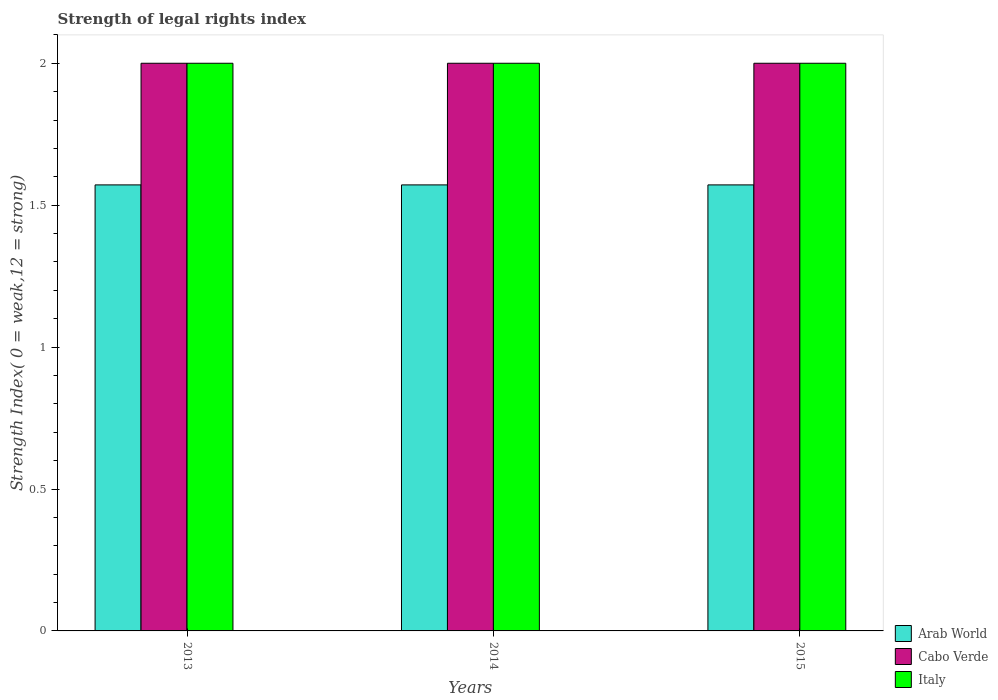How many different coloured bars are there?
Offer a terse response. 3. Are the number of bars per tick equal to the number of legend labels?
Keep it short and to the point. Yes. Are the number of bars on each tick of the X-axis equal?
Give a very brief answer. Yes. What is the label of the 3rd group of bars from the left?
Offer a terse response. 2015. What is the strength index in Italy in 2015?
Give a very brief answer. 2. Across all years, what is the maximum strength index in Arab World?
Offer a terse response. 1.57. Across all years, what is the minimum strength index in Arab World?
Provide a succinct answer. 1.57. In which year was the strength index in Cabo Verde maximum?
Keep it short and to the point. 2013. In which year was the strength index in Arab World minimum?
Provide a succinct answer. 2013. What is the difference between the strength index in Arab World in 2015 and the strength index in Italy in 2013?
Ensure brevity in your answer.  -0.43. What is the average strength index in Arab World per year?
Your answer should be compact. 1.57. In how many years, is the strength index in Cabo Verde greater than 0.5?
Make the answer very short. 3. Is the strength index in Italy in 2013 less than that in 2015?
Ensure brevity in your answer.  No. Is the difference between the strength index in Italy in 2013 and 2014 greater than the difference between the strength index in Cabo Verde in 2013 and 2014?
Offer a terse response. No. What does the 1st bar from the left in 2014 represents?
Give a very brief answer. Arab World. What does the 2nd bar from the right in 2014 represents?
Your answer should be compact. Cabo Verde. How many bars are there?
Your answer should be very brief. 9. How many years are there in the graph?
Provide a succinct answer. 3. Are the values on the major ticks of Y-axis written in scientific E-notation?
Keep it short and to the point. No. Does the graph contain any zero values?
Make the answer very short. No. Does the graph contain grids?
Offer a terse response. No. How many legend labels are there?
Make the answer very short. 3. What is the title of the graph?
Provide a short and direct response. Strength of legal rights index. What is the label or title of the Y-axis?
Provide a short and direct response. Strength Index( 0 = weak,12 = strong). What is the Strength Index( 0 = weak,12 = strong) of Arab World in 2013?
Make the answer very short. 1.57. What is the Strength Index( 0 = weak,12 = strong) of Cabo Verde in 2013?
Your response must be concise. 2. What is the Strength Index( 0 = weak,12 = strong) in Arab World in 2014?
Your answer should be very brief. 1.57. What is the Strength Index( 0 = weak,12 = strong) of Italy in 2014?
Keep it short and to the point. 2. What is the Strength Index( 0 = weak,12 = strong) of Arab World in 2015?
Provide a succinct answer. 1.57. What is the Strength Index( 0 = weak,12 = strong) in Cabo Verde in 2015?
Your answer should be compact. 2. Across all years, what is the maximum Strength Index( 0 = weak,12 = strong) of Arab World?
Give a very brief answer. 1.57. Across all years, what is the maximum Strength Index( 0 = weak,12 = strong) of Italy?
Your answer should be compact. 2. Across all years, what is the minimum Strength Index( 0 = weak,12 = strong) in Arab World?
Provide a short and direct response. 1.57. Across all years, what is the minimum Strength Index( 0 = weak,12 = strong) in Cabo Verde?
Make the answer very short. 2. What is the total Strength Index( 0 = weak,12 = strong) of Arab World in the graph?
Make the answer very short. 4.71. What is the difference between the Strength Index( 0 = weak,12 = strong) of Italy in 2013 and that in 2014?
Your response must be concise. 0. What is the difference between the Strength Index( 0 = weak,12 = strong) of Arab World in 2013 and that in 2015?
Your response must be concise. 0. What is the difference between the Strength Index( 0 = weak,12 = strong) in Italy in 2013 and that in 2015?
Provide a succinct answer. 0. What is the difference between the Strength Index( 0 = weak,12 = strong) of Arab World in 2013 and the Strength Index( 0 = weak,12 = strong) of Cabo Verde in 2014?
Provide a short and direct response. -0.43. What is the difference between the Strength Index( 0 = weak,12 = strong) of Arab World in 2013 and the Strength Index( 0 = weak,12 = strong) of Italy in 2014?
Offer a very short reply. -0.43. What is the difference between the Strength Index( 0 = weak,12 = strong) of Cabo Verde in 2013 and the Strength Index( 0 = weak,12 = strong) of Italy in 2014?
Keep it short and to the point. 0. What is the difference between the Strength Index( 0 = weak,12 = strong) of Arab World in 2013 and the Strength Index( 0 = weak,12 = strong) of Cabo Verde in 2015?
Give a very brief answer. -0.43. What is the difference between the Strength Index( 0 = weak,12 = strong) in Arab World in 2013 and the Strength Index( 0 = weak,12 = strong) in Italy in 2015?
Ensure brevity in your answer.  -0.43. What is the difference between the Strength Index( 0 = weak,12 = strong) of Cabo Verde in 2013 and the Strength Index( 0 = weak,12 = strong) of Italy in 2015?
Your answer should be compact. 0. What is the difference between the Strength Index( 0 = weak,12 = strong) in Arab World in 2014 and the Strength Index( 0 = weak,12 = strong) in Cabo Verde in 2015?
Your answer should be compact. -0.43. What is the difference between the Strength Index( 0 = weak,12 = strong) of Arab World in 2014 and the Strength Index( 0 = weak,12 = strong) of Italy in 2015?
Provide a short and direct response. -0.43. What is the average Strength Index( 0 = weak,12 = strong) in Arab World per year?
Make the answer very short. 1.57. What is the average Strength Index( 0 = weak,12 = strong) in Cabo Verde per year?
Offer a very short reply. 2. In the year 2013, what is the difference between the Strength Index( 0 = weak,12 = strong) of Arab World and Strength Index( 0 = weak,12 = strong) of Cabo Verde?
Your response must be concise. -0.43. In the year 2013, what is the difference between the Strength Index( 0 = weak,12 = strong) in Arab World and Strength Index( 0 = weak,12 = strong) in Italy?
Make the answer very short. -0.43. In the year 2014, what is the difference between the Strength Index( 0 = weak,12 = strong) in Arab World and Strength Index( 0 = weak,12 = strong) in Cabo Verde?
Ensure brevity in your answer.  -0.43. In the year 2014, what is the difference between the Strength Index( 0 = weak,12 = strong) in Arab World and Strength Index( 0 = weak,12 = strong) in Italy?
Provide a succinct answer. -0.43. In the year 2015, what is the difference between the Strength Index( 0 = weak,12 = strong) of Arab World and Strength Index( 0 = weak,12 = strong) of Cabo Verde?
Provide a short and direct response. -0.43. In the year 2015, what is the difference between the Strength Index( 0 = weak,12 = strong) of Arab World and Strength Index( 0 = weak,12 = strong) of Italy?
Provide a short and direct response. -0.43. What is the ratio of the Strength Index( 0 = weak,12 = strong) in Arab World in 2013 to that in 2014?
Ensure brevity in your answer.  1. What is the ratio of the Strength Index( 0 = weak,12 = strong) of Italy in 2013 to that in 2015?
Ensure brevity in your answer.  1. What is the ratio of the Strength Index( 0 = weak,12 = strong) in Arab World in 2014 to that in 2015?
Provide a short and direct response. 1. What is the ratio of the Strength Index( 0 = weak,12 = strong) of Cabo Verde in 2014 to that in 2015?
Offer a terse response. 1. What is the ratio of the Strength Index( 0 = weak,12 = strong) of Italy in 2014 to that in 2015?
Offer a terse response. 1. What is the difference between the highest and the second highest Strength Index( 0 = weak,12 = strong) in Cabo Verde?
Your response must be concise. 0. What is the difference between the highest and the second highest Strength Index( 0 = weak,12 = strong) in Italy?
Your answer should be compact. 0. What is the difference between the highest and the lowest Strength Index( 0 = weak,12 = strong) of Arab World?
Make the answer very short. 0. What is the difference between the highest and the lowest Strength Index( 0 = weak,12 = strong) of Cabo Verde?
Offer a terse response. 0. What is the difference between the highest and the lowest Strength Index( 0 = weak,12 = strong) of Italy?
Make the answer very short. 0. 